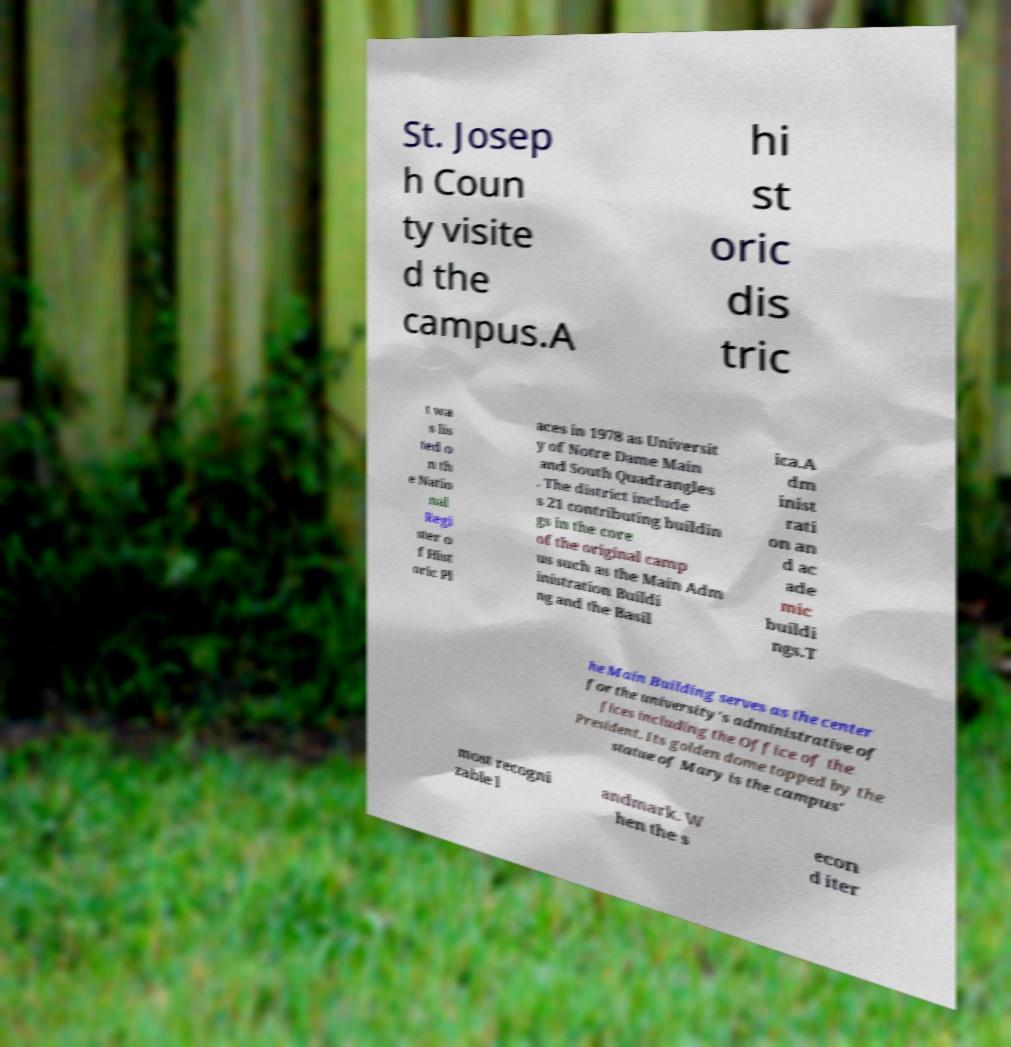Can you read and provide the text displayed in the image?This photo seems to have some interesting text. Can you extract and type it out for me? St. Josep h Coun ty visite d the campus.A hi st oric dis tric t wa s lis ted o n th e Natio nal Regi ster o f Hist oric Pl aces in 1978 as Universit y of Notre Dame Main and South Quadrangles . The district include s 21 contributing buildin gs in the core of the original camp us such as the Main Adm inistration Buildi ng and the Basil ica.A dm inist rati on an d ac ade mic buildi ngs.T he Main Building serves as the center for the university's administrative of fices including the Office of the President. Its golden dome topped by the statue of Mary is the campus' most recogni zable l andmark. W hen the s econ d iter 